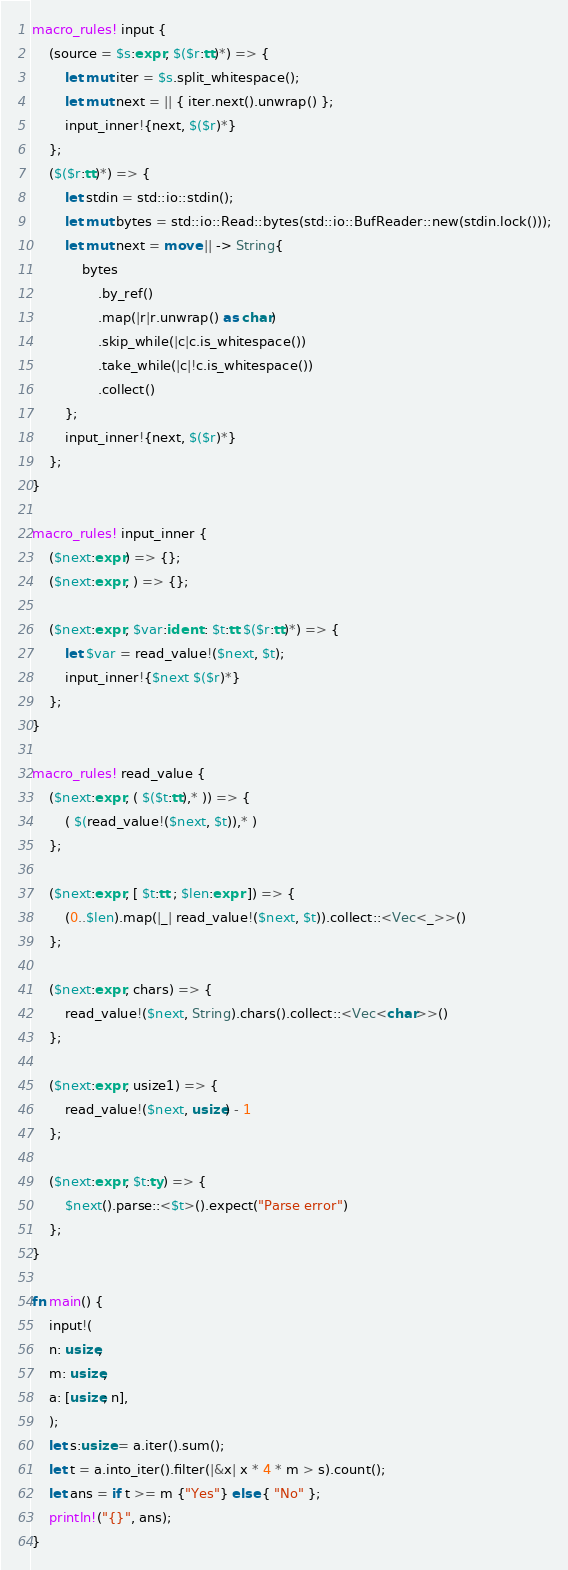<code> <loc_0><loc_0><loc_500><loc_500><_Rust_>macro_rules! input {
    (source = $s:expr, $($r:tt)*) => {
        let mut iter = $s.split_whitespace();
        let mut next = || { iter.next().unwrap() };
        input_inner!{next, $($r)*}
    };
    ($($r:tt)*) => {
        let stdin = std::io::stdin();
        let mut bytes = std::io::Read::bytes(std::io::BufReader::new(stdin.lock()));
        let mut next = move || -> String{
            bytes
                .by_ref()
                .map(|r|r.unwrap() as char)
                .skip_while(|c|c.is_whitespace())
                .take_while(|c|!c.is_whitespace())
                .collect()
        };
        input_inner!{next, $($r)*}
    };
}

macro_rules! input_inner {
    ($next:expr) => {};
    ($next:expr, ) => {};

    ($next:expr, $var:ident : $t:tt $($r:tt)*) => {
        let $var = read_value!($next, $t);
        input_inner!{$next $($r)*}
    };
}

macro_rules! read_value {
    ($next:expr, ( $($t:tt),* )) => {
        ( $(read_value!($next, $t)),* )
    };

    ($next:expr, [ $t:tt ; $len:expr ]) => {
        (0..$len).map(|_| read_value!($next, $t)).collect::<Vec<_>>()
    };

    ($next:expr, chars) => {
        read_value!($next, String).chars().collect::<Vec<char>>()
    };

    ($next:expr, usize1) => {
        read_value!($next, usize) - 1
    };

    ($next:expr, $t:ty) => {
        $next().parse::<$t>().expect("Parse error")
    };
}

fn main() {
    input!(
    n: usize,
    m: usize,
    a: [usize; n],
    );
    let s:usize = a.iter().sum();
    let t = a.into_iter().filter(|&x| x * 4 * m > s).count();
    let ans = if t >= m {"Yes"} else { "No" };
    println!("{}", ans);
}

</code> 